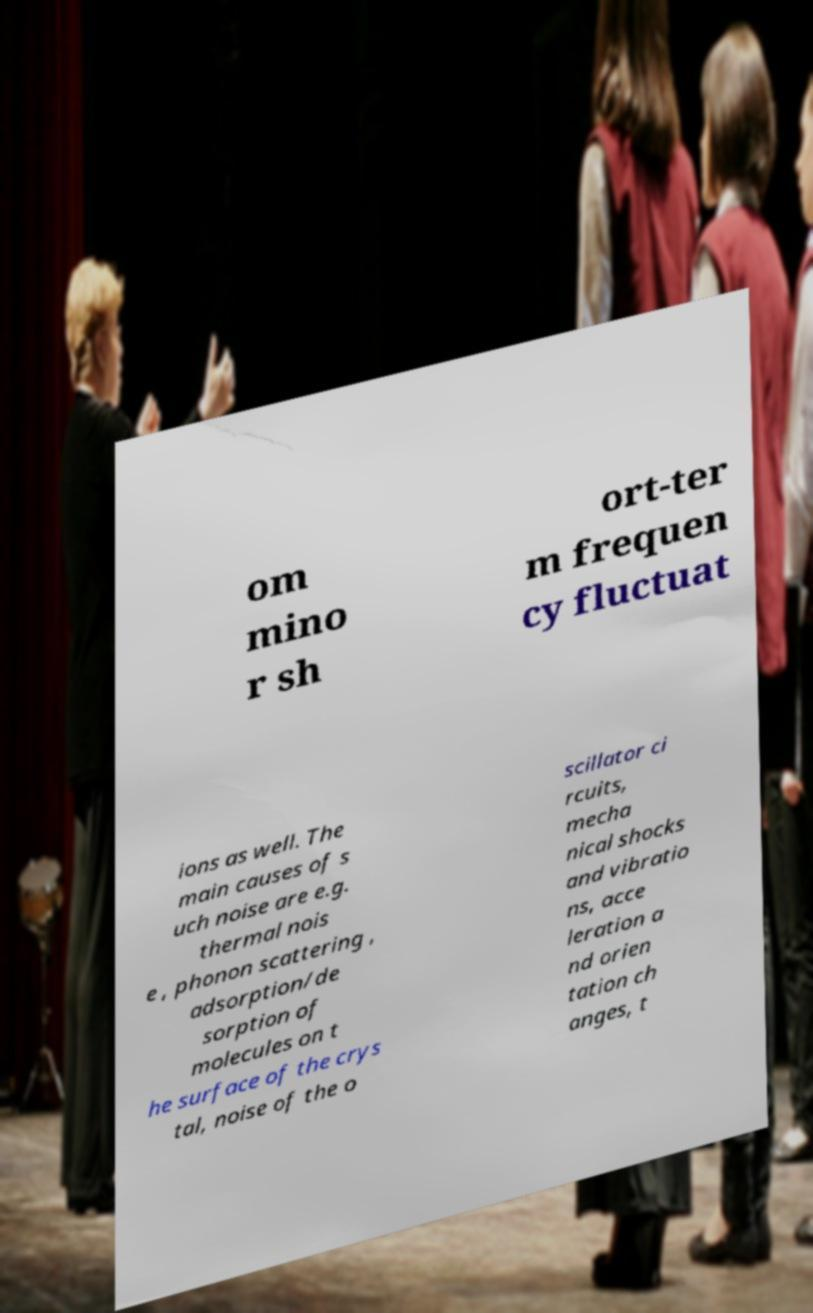There's text embedded in this image that I need extracted. Can you transcribe it verbatim? om mino r sh ort-ter m frequen cy fluctuat ions as well. The main causes of s uch noise are e.g. thermal nois e , phonon scattering , adsorption/de sorption of molecules on t he surface of the crys tal, noise of the o scillator ci rcuits, mecha nical shocks and vibratio ns, acce leration a nd orien tation ch anges, t 